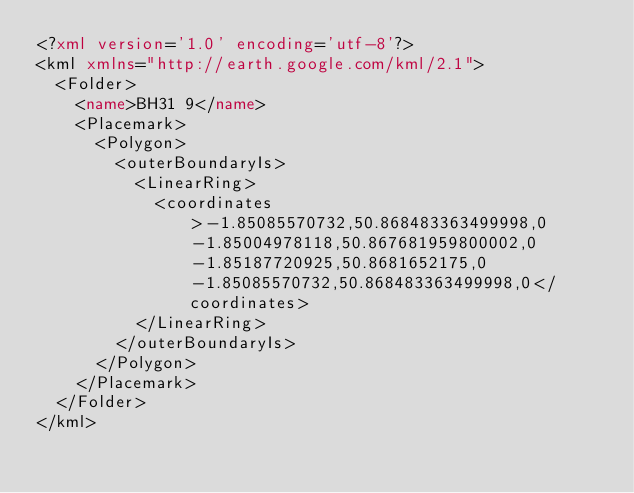Convert code to text. <code><loc_0><loc_0><loc_500><loc_500><_XML_><?xml version='1.0' encoding='utf-8'?>
<kml xmlns="http://earth.google.com/kml/2.1">
  <Folder>
    <name>BH31 9</name>
    <Placemark>
      <Polygon>
        <outerBoundaryIs>
          <LinearRing>
            <coordinates>-1.85085570732,50.868483363499998,0 -1.85004978118,50.867681959800002,0 -1.85187720925,50.8681652175,0 -1.85085570732,50.868483363499998,0</coordinates>
          </LinearRing>
        </outerBoundaryIs>
      </Polygon>
    </Placemark>
  </Folder>
</kml>
</code> 